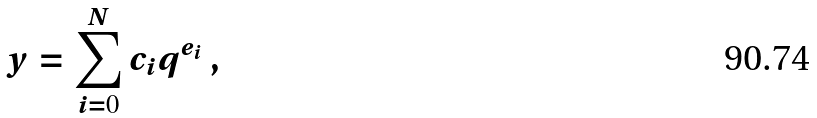Convert formula to latex. <formula><loc_0><loc_0><loc_500><loc_500>y = \sum _ { i = 0 } ^ { N } c _ { i } q ^ { e _ { i } } \, ,</formula> 